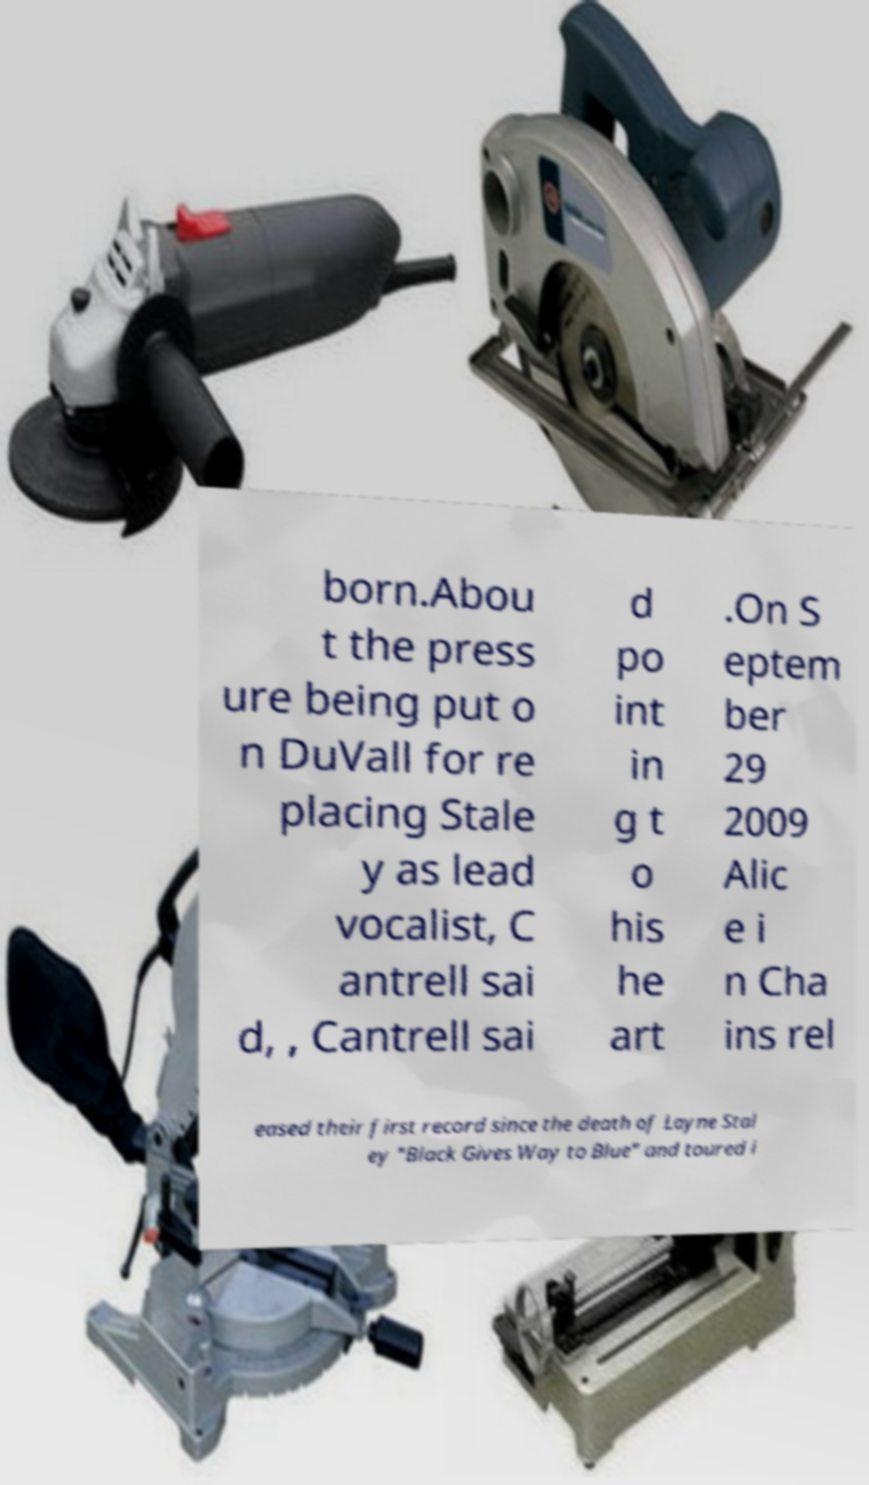Can you accurately transcribe the text from the provided image for me? born.Abou t the press ure being put o n DuVall for re placing Stale y as lead vocalist, C antrell sai d, , Cantrell sai d po int in g t o his he art .On S eptem ber 29 2009 Alic e i n Cha ins rel eased their first record since the death of Layne Stal ey "Black Gives Way to Blue" and toured i 